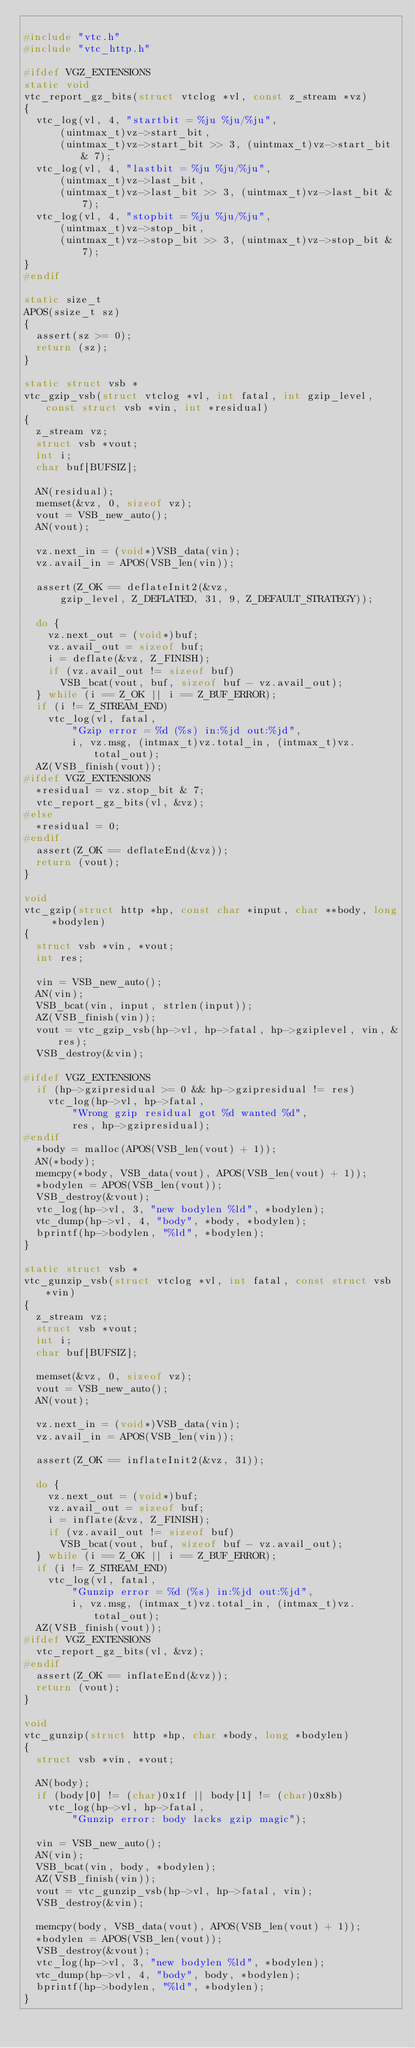Convert code to text. <code><loc_0><loc_0><loc_500><loc_500><_C_>
#include "vtc.h"
#include "vtc_http.h"

#ifdef VGZ_EXTENSIONS
static void
vtc_report_gz_bits(struct vtclog *vl, const z_stream *vz)
{
	vtc_log(vl, 4, "startbit = %ju %ju/%ju",
	    (uintmax_t)vz->start_bit,
	    (uintmax_t)vz->start_bit >> 3, (uintmax_t)vz->start_bit & 7);
	vtc_log(vl, 4, "lastbit = %ju %ju/%ju",
	    (uintmax_t)vz->last_bit,
	    (uintmax_t)vz->last_bit >> 3, (uintmax_t)vz->last_bit & 7);
	vtc_log(vl, 4, "stopbit = %ju %ju/%ju",
	    (uintmax_t)vz->stop_bit,
	    (uintmax_t)vz->stop_bit >> 3, (uintmax_t)vz->stop_bit & 7);
}
#endif

static size_t
APOS(ssize_t sz)
{
	assert(sz >= 0);
	return (sz);
}

static struct vsb *
vtc_gzip_vsb(struct vtclog *vl, int fatal, int gzip_level, const struct vsb *vin, int *residual)
{
	z_stream vz;
	struct vsb *vout;
	int i;
	char buf[BUFSIZ];

	AN(residual);
	memset(&vz, 0, sizeof vz);
	vout = VSB_new_auto();
	AN(vout);

	vz.next_in = (void*)VSB_data(vin);
	vz.avail_in = APOS(VSB_len(vin));

	assert(Z_OK == deflateInit2(&vz,
	    gzip_level, Z_DEFLATED, 31, 9, Z_DEFAULT_STRATEGY));

	do {
		vz.next_out = (void*)buf;
		vz.avail_out = sizeof buf;
		i = deflate(&vz, Z_FINISH);
		if (vz.avail_out != sizeof buf)
			VSB_bcat(vout, buf, sizeof buf - vz.avail_out);
	} while (i == Z_OK || i == Z_BUF_ERROR);
	if (i != Z_STREAM_END)
		vtc_log(vl, fatal,
		    "Gzip error = %d (%s) in:%jd out:%jd",
		    i, vz.msg, (intmax_t)vz.total_in, (intmax_t)vz.total_out);
	AZ(VSB_finish(vout));
#ifdef VGZ_EXTENSIONS
	*residual = vz.stop_bit & 7;
	vtc_report_gz_bits(vl, &vz);
#else
	*residual = 0;
#endif
	assert(Z_OK == deflateEnd(&vz));
	return (vout);
}

void
vtc_gzip(struct http *hp, const char *input, char **body, long *bodylen)
{
	struct vsb *vin, *vout;
	int res;

	vin = VSB_new_auto();
	AN(vin);
	VSB_bcat(vin, input, strlen(input));
	AZ(VSB_finish(vin));
	vout = vtc_gzip_vsb(hp->vl, hp->fatal, hp->gziplevel, vin, &res);
	VSB_destroy(&vin);

#ifdef VGZ_EXTENSIONS
	if (hp->gzipresidual >= 0 && hp->gzipresidual != res)
		vtc_log(hp->vl, hp->fatal,
		    "Wrong gzip residual got %d wanted %d",
		    res, hp->gzipresidual);
#endif
	*body = malloc(APOS(VSB_len(vout) + 1));
	AN(*body);
	memcpy(*body, VSB_data(vout), APOS(VSB_len(vout) + 1));
	*bodylen = APOS(VSB_len(vout));
	VSB_destroy(&vout);
	vtc_log(hp->vl, 3, "new bodylen %ld", *bodylen);
	vtc_dump(hp->vl, 4, "body", *body, *bodylen);
	bprintf(hp->bodylen, "%ld", *bodylen);
}

static struct vsb *
vtc_gunzip_vsb(struct vtclog *vl, int fatal, const struct vsb *vin)
{
	z_stream vz;
	struct vsb *vout;
	int i;
	char buf[BUFSIZ];

	memset(&vz, 0, sizeof vz);
	vout = VSB_new_auto();
	AN(vout);

	vz.next_in = (void*)VSB_data(vin);
	vz.avail_in = APOS(VSB_len(vin));

	assert(Z_OK == inflateInit2(&vz, 31));

	do {
		vz.next_out = (void*)buf;
		vz.avail_out = sizeof buf;
		i = inflate(&vz, Z_FINISH);
		if (vz.avail_out != sizeof buf)
			VSB_bcat(vout, buf, sizeof buf - vz.avail_out);
	} while (i == Z_OK || i == Z_BUF_ERROR);
	if (i != Z_STREAM_END)
		vtc_log(vl, fatal,
		    "Gunzip error = %d (%s) in:%jd out:%jd",
		    i, vz.msg, (intmax_t)vz.total_in, (intmax_t)vz.total_out);
	AZ(VSB_finish(vout));
#ifdef VGZ_EXTENSIONS
	vtc_report_gz_bits(vl, &vz);
#endif
	assert(Z_OK == inflateEnd(&vz));
	return (vout);
}

void
vtc_gunzip(struct http *hp, char *body, long *bodylen)
{
	struct vsb *vin, *vout;

	AN(body);
	if (body[0] != (char)0x1f || body[1] != (char)0x8b)
		vtc_log(hp->vl, hp->fatal,
		    "Gunzip error: body lacks gzip magic");

	vin = VSB_new_auto();
	AN(vin);
	VSB_bcat(vin, body, *bodylen);
	AZ(VSB_finish(vin));
	vout = vtc_gunzip_vsb(hp->vl, hp->fatal, vin);
	VSB_destroy(&vin);

	memcpy(body, VSB_data(vout), APOS(VSB_len(vout) + 1));
	*bodylen = APOS(VSB_len(vout));
	VSB_destroy(&vout);
	vtc_log(hp->vl, 3, "new bodylen %ld", *bodylen);
	vtc_dump(hp->vl, 4, "body", body, *bodylen);
	bprintf(hp->bodylen, "%ld", *bodylen);
}
</code> 